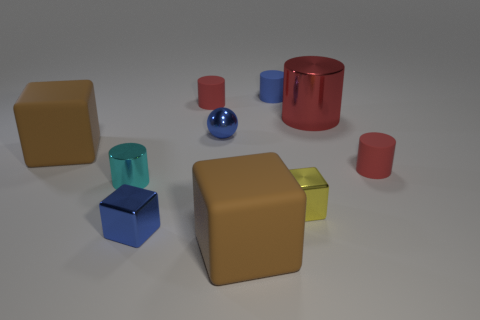Subtract all brown cubes. How many red cylinders are left? 3 Subtract 1 cubes. How many cubes are left? 3 Subtract all blue cylinders. How many cylinders are left? 4 Subtract all large cylinders. How many cylinders are left? 4 Subtract all green cylinders. Subtract all red cubes. How many cylinders are left? 5 Subtract all balls. How many objects are left? 9 Add 2 blue things. How many blue things are left? 5 Add 8 small yellow objects. How many small yellow objects exist? 9 Subtract 0 purple spheres. How many objects are left? 10 Subtract all big gray cylinders. Subtract all small blue cylinders. How many objects are left? 9 